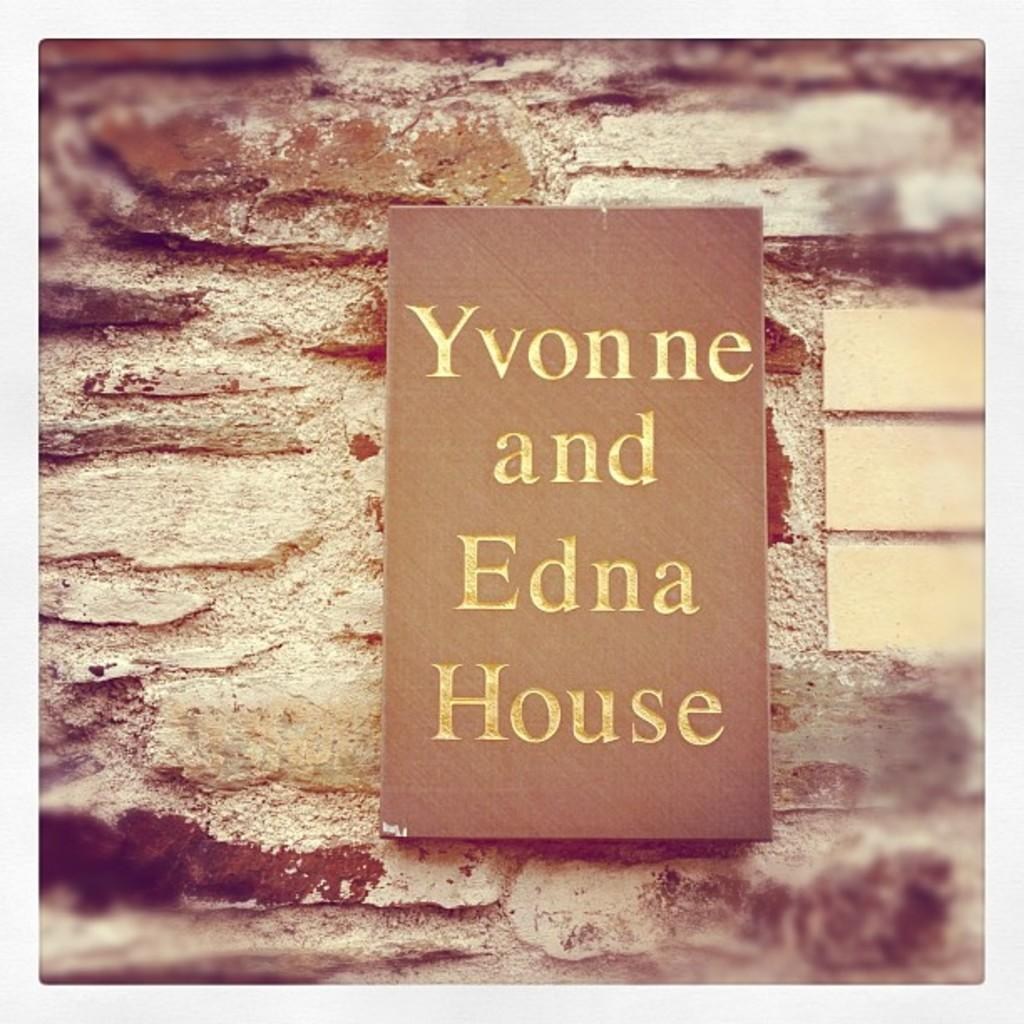<image>
Write a terse but informative summary of the picture. A sign for the Yvonne and Edna House is on a stone background. 